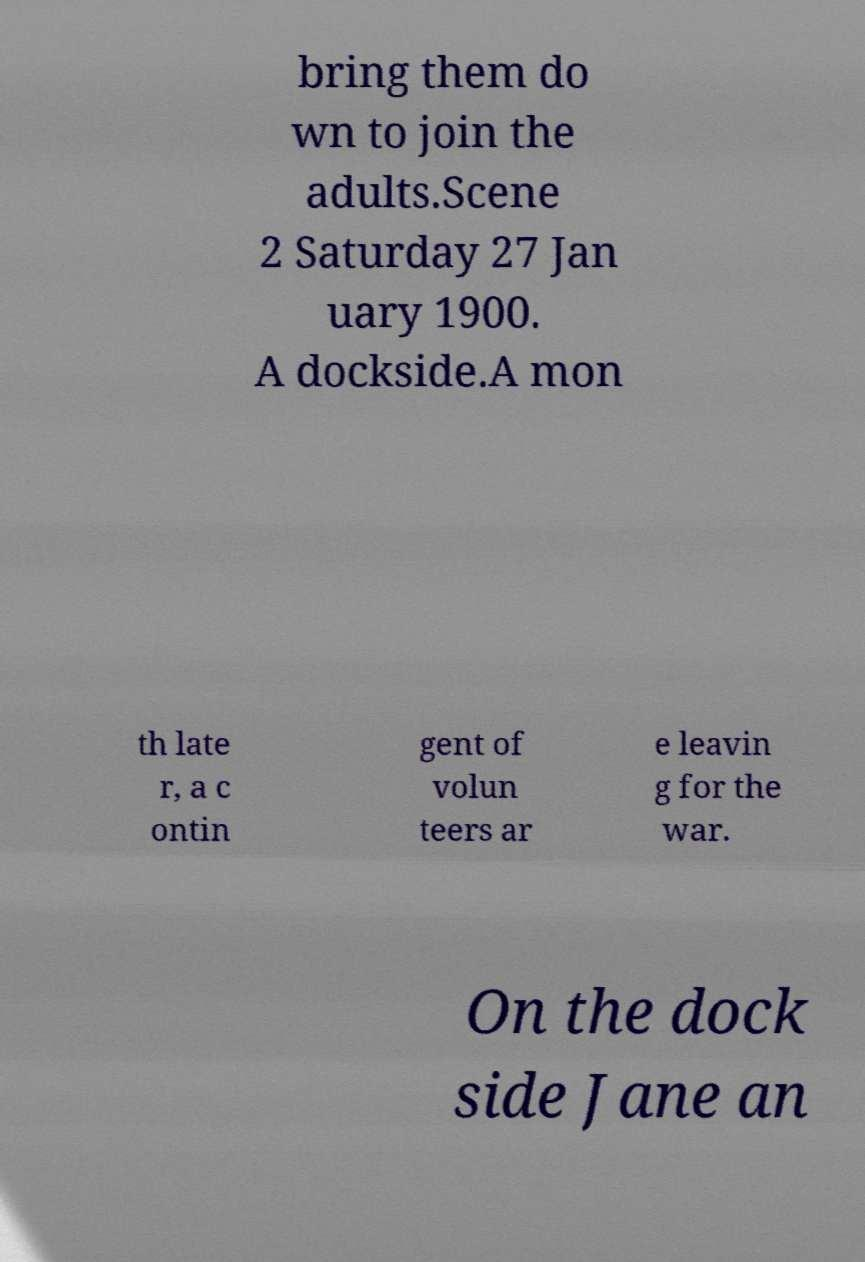Can you read and provide the text displayed in the image?This photo seems to have some interesting text. Can you extract and type it out for me? bring them do wn to join the adults.Scene 2 Saturday 27 Jan uary 1900. A dockside.A mon th late r, a c ontin gent of volun teers ar e leavin g for the war. On the dock side Jane an 